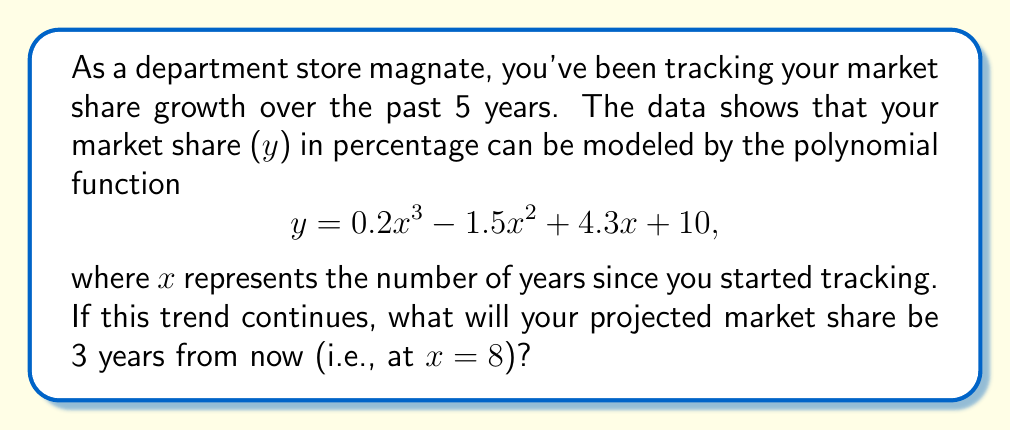Provide a solution to this math problem. To solve this problem, we need to follow these steps:

1. Identify the given polynomial function:
   $y = 0.2x^3 - 1.5x^2 + 4.3x + 10$

2. Determine the value of x:
   Current time: x = 5 (5 years of tracking)
   Projected time: 3 years from now
   x = 5 + 3 = 8

3. Substitute x = 8 into the polynomial function:

   $y = 0.2(8)^3 - 1.5(8)^2 + 4.3(8) + 10$

4. Evaluate each term:
   $0.2(8)^3 = 0.2 * 512 = 102.4$
   $-1.5(8)^2 = -1.5 * 64 = -96$
   $4.3(8) = 34.4$
   $10$ (constant term)

5. Sum up all the terms:
   $y = 102.4 - 96 + 34.4 + 10 = 50.8$

Therefore, the projected market share 3 years from now will be 50.8%.
Answer: 50.8% 